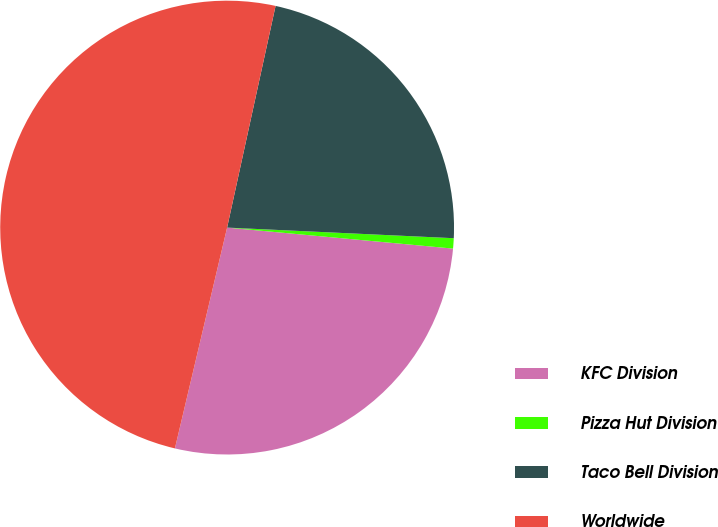<chart> <loc_0><loc_0><loc_500><loc_500><pie_chart><fcel>KFC Division<fcel>Pizza Hut Division<fcel>Taco Bell Division<fcel>Worldwide<nl><fcel>27.22%<fcel>0.73%<fcel>22.32%<fcel>49.73%<nl></chart> 